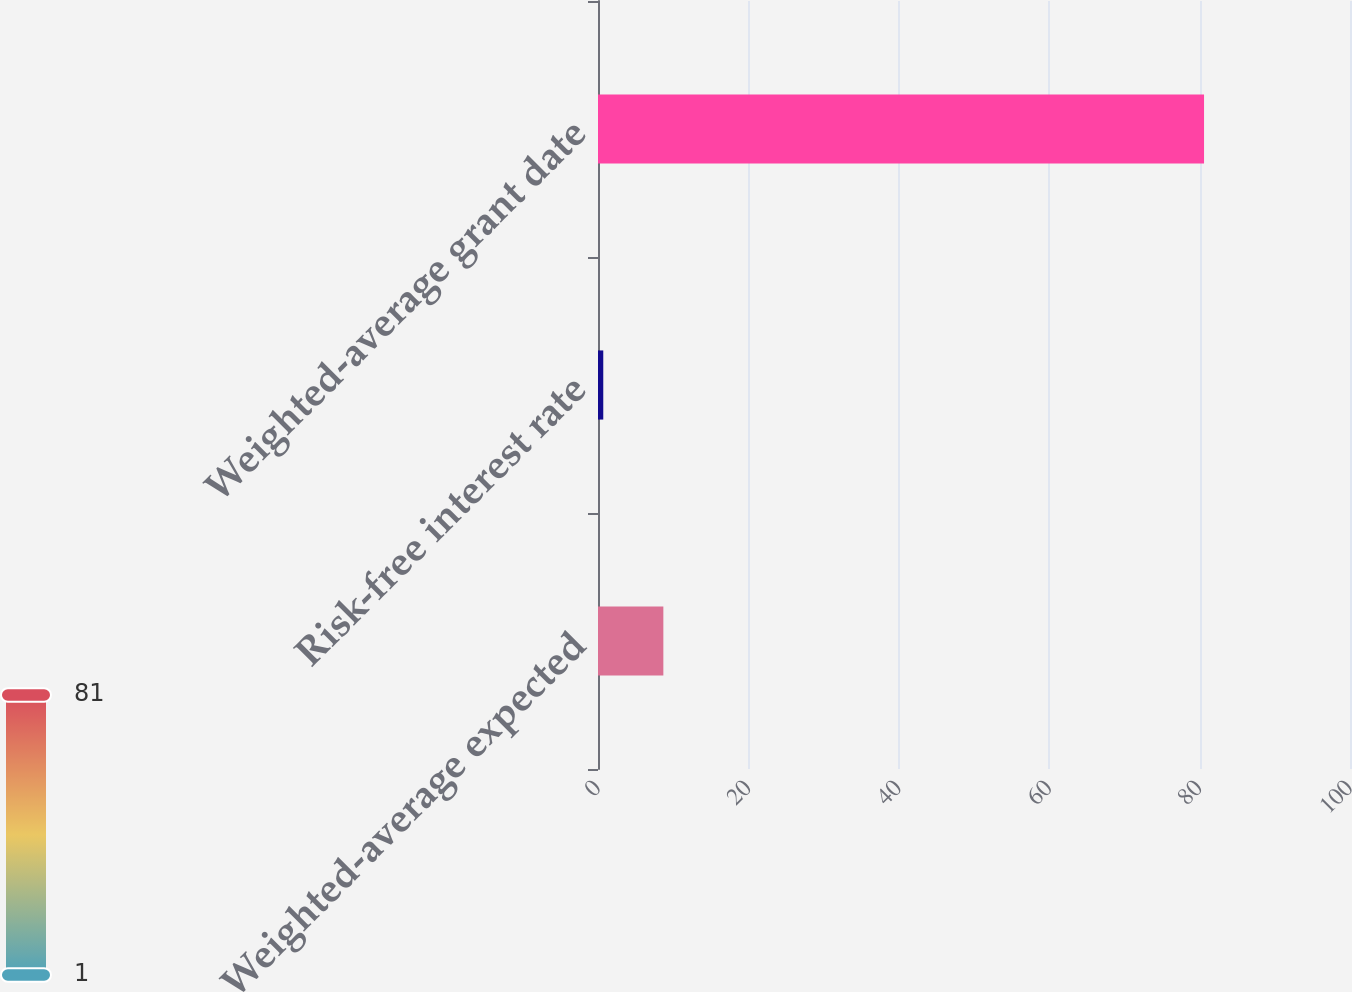Convert chart. <chart><loc_0><loc_0><loc_500><loc_500><bar_chart><fcel>Weighted-average expected<fcel>Risk-free interest rate<fcel>Weighted-average grant date<nl><fcel>8.69<fcel>0.7<fcel>80.59<nl></chart> 